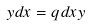<formula> <loc_0><loc_0><loc_500><loc_500>y d x = q d x y</formula> 